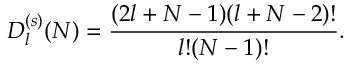Convert formula to latex. <formula><loc_0><loc_0><loc_500><loc_500>D _ { l } ^ { ( s ) } ( N ) = \frac { ( 2 l + N - 1 ) ( l + N - 2 ) ! } { l ! ( N - 1 ) ! } .</formula> 